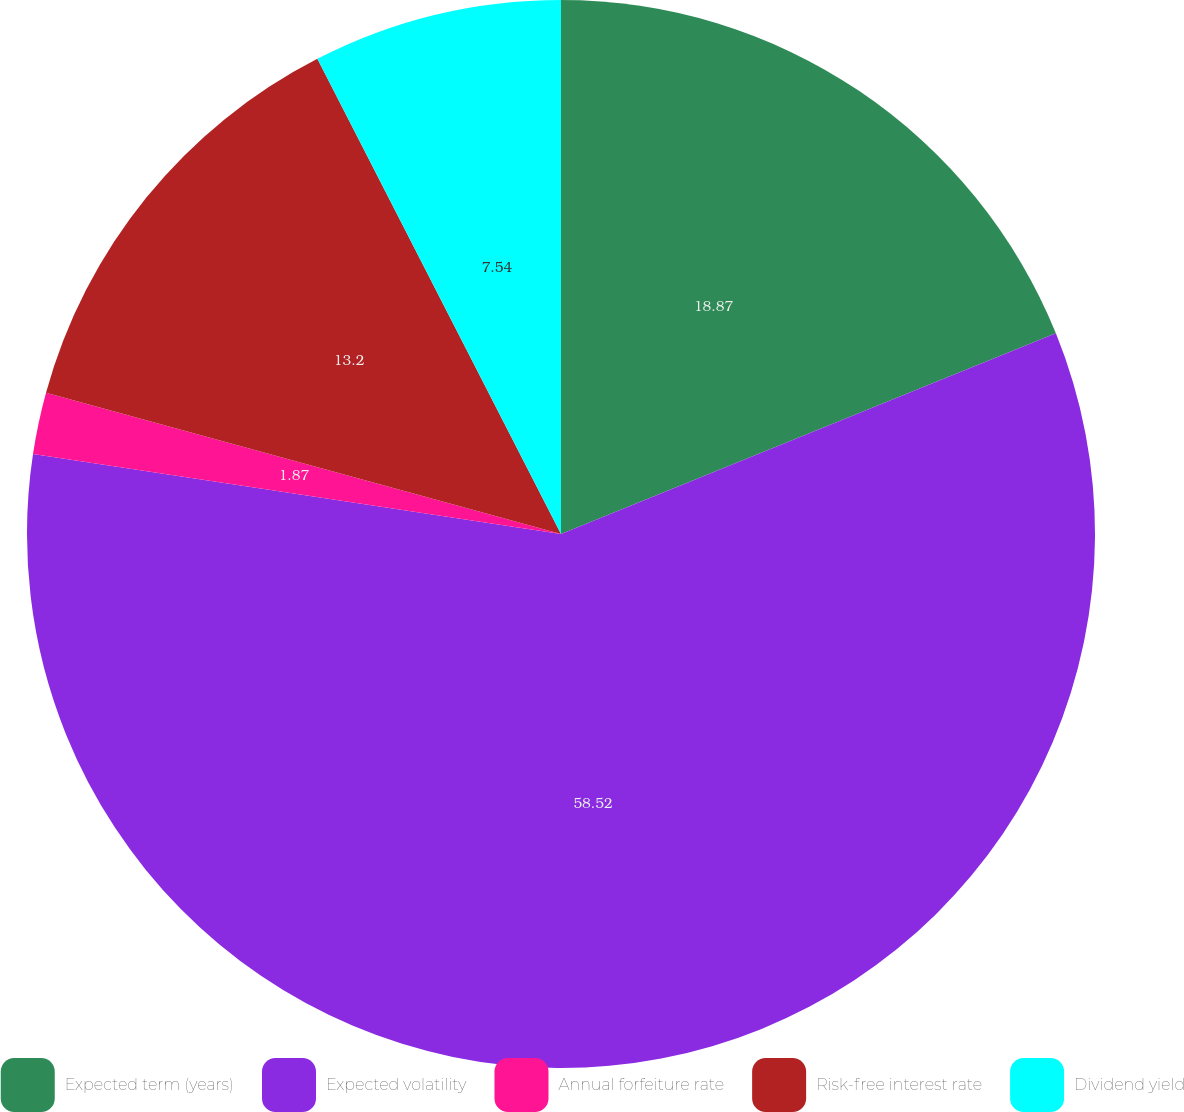Convert chart. <chart><loc_0><loc_0><loc_500><loc_500><pie_chart><fcel>Expected term (years)<fcel>Expected volatility<fcel>Annual forfeiture rate<fcel>Risk-free interest rate<fcel>Dividend yield<nl><fcel>18.87%<fcel>58.52%<fcel>1.87%<fcel>13.2%<fcel>7.54%<nl></chart> 